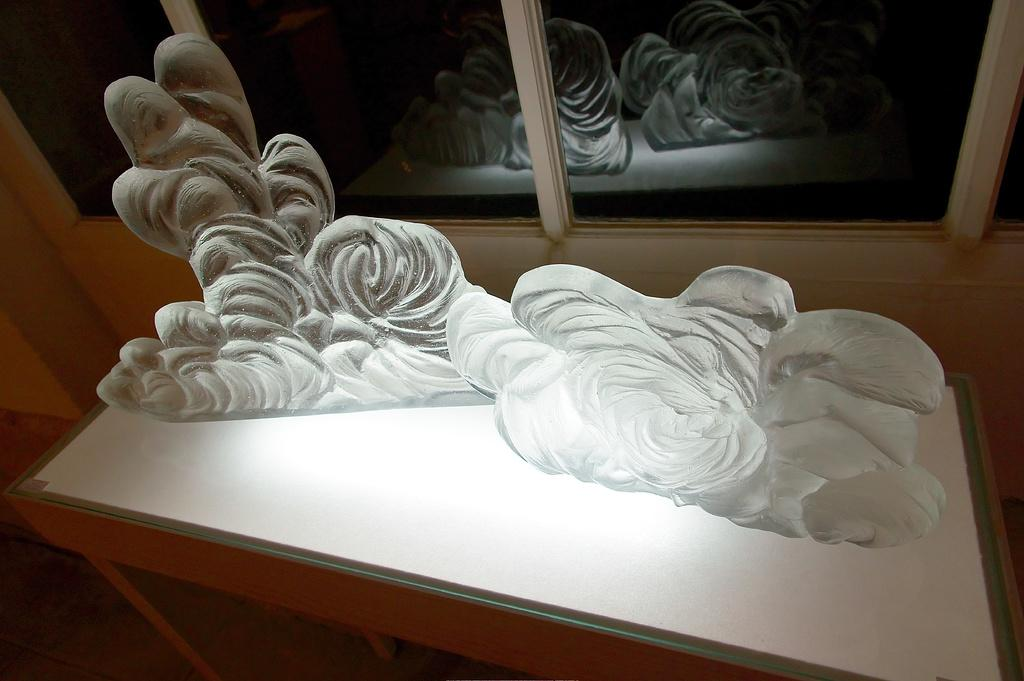What is the main subject of the image? There is a sculpture in the image. Where is the sculpture located? The sculpture is placed on a table. What can be seen in the background of the image? There is a window and a wall in the image. What type of dress is the sculpture wearing in the image? The sculpture is not a person and therefore cannot wear a dress. The sculpture is an inanimate object made of a material like stone or metal. 